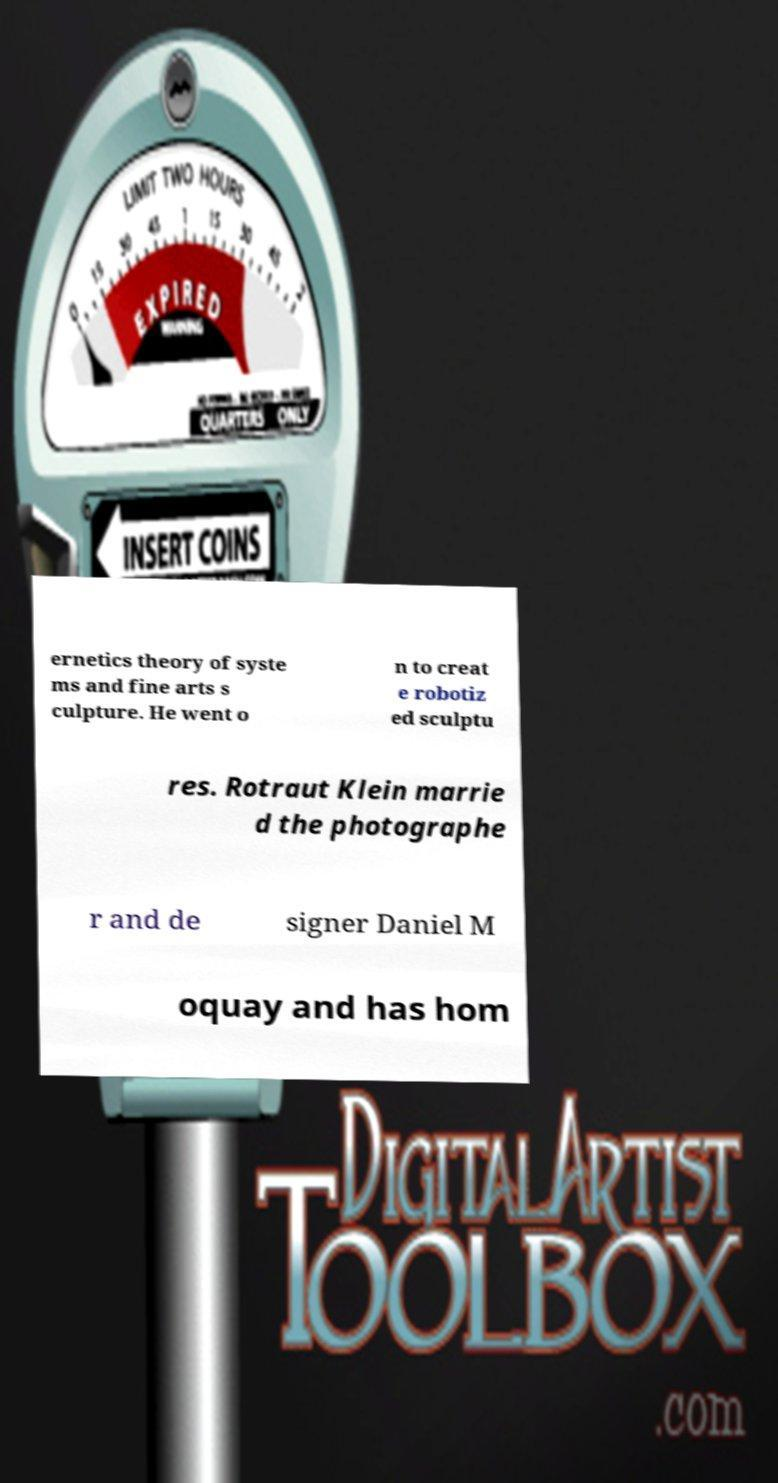Please read and relay the text visible in this image. What does it say? ernetics theory of syste ms and fine arts s culpture. He went o n to creat e robotiz ed sculptu res. Rotraut Klein marrie d the photographe r and de signer Daniel M oquay and has hom 